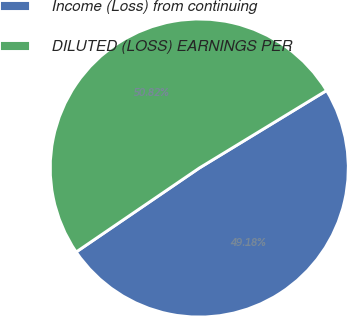Convert chart to OTSL. <chart><loc_0><loc_0><loc_500><loc_500><pie_chart><fcel>Income (Loss) from continuing<fcel>DILUTED (LOSS) EARNINGS PER<nl><fcel>49.18%<fcel>50.82%<nl></chart> 